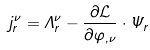<formula> <loc_0><loc_0><loc_500><loc_500>j _ { r } ^ { \nu } = \Lambda _ { r } ^ { \nu } - { \frac { \partial { \mathcal { L } } } { \partial \varphi _ { , \nu } } } \cdot \Psi _ { r }</formula> 